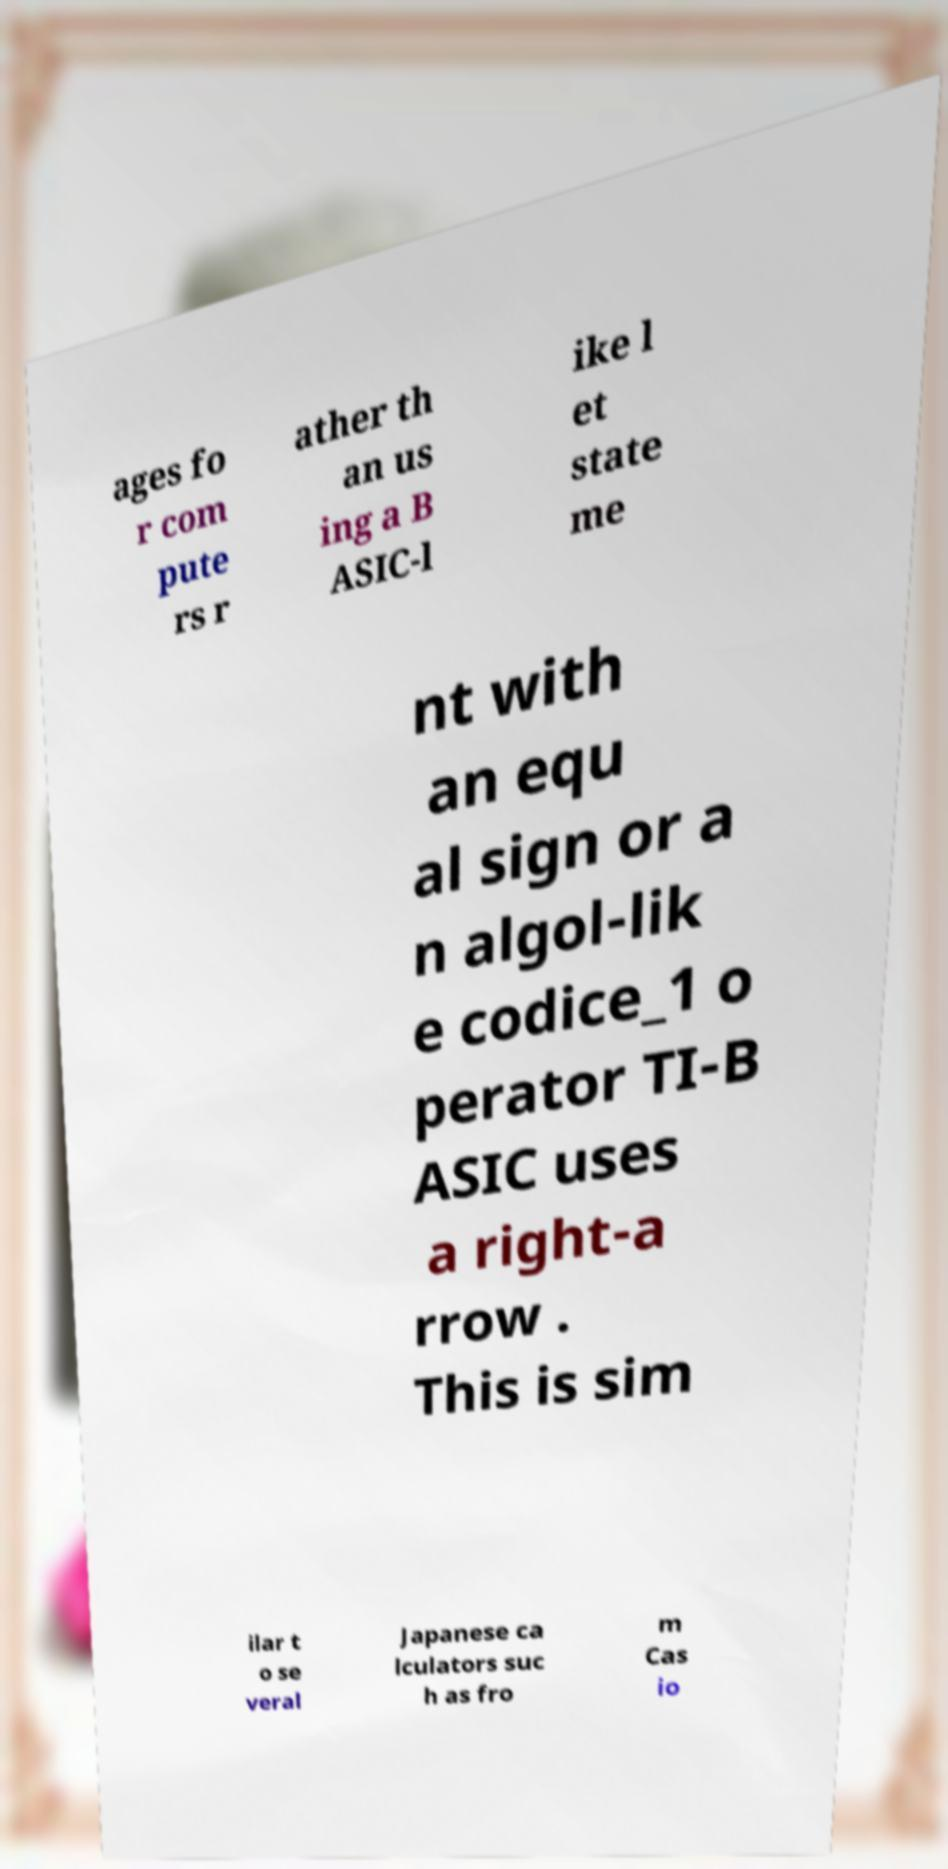Could you assist in decoding the text presented in this image and type it out clearly? ages fo r com pute rs r ather th an us ing a B ASIC-l ike l et state me nt with an equ al sign or a n algol-lik e codice_1 o perator TI-B ASIC uses a right-a rrow . This is sim ilar t o se veral Japanese ca lculators suc h as fro m Cas io 